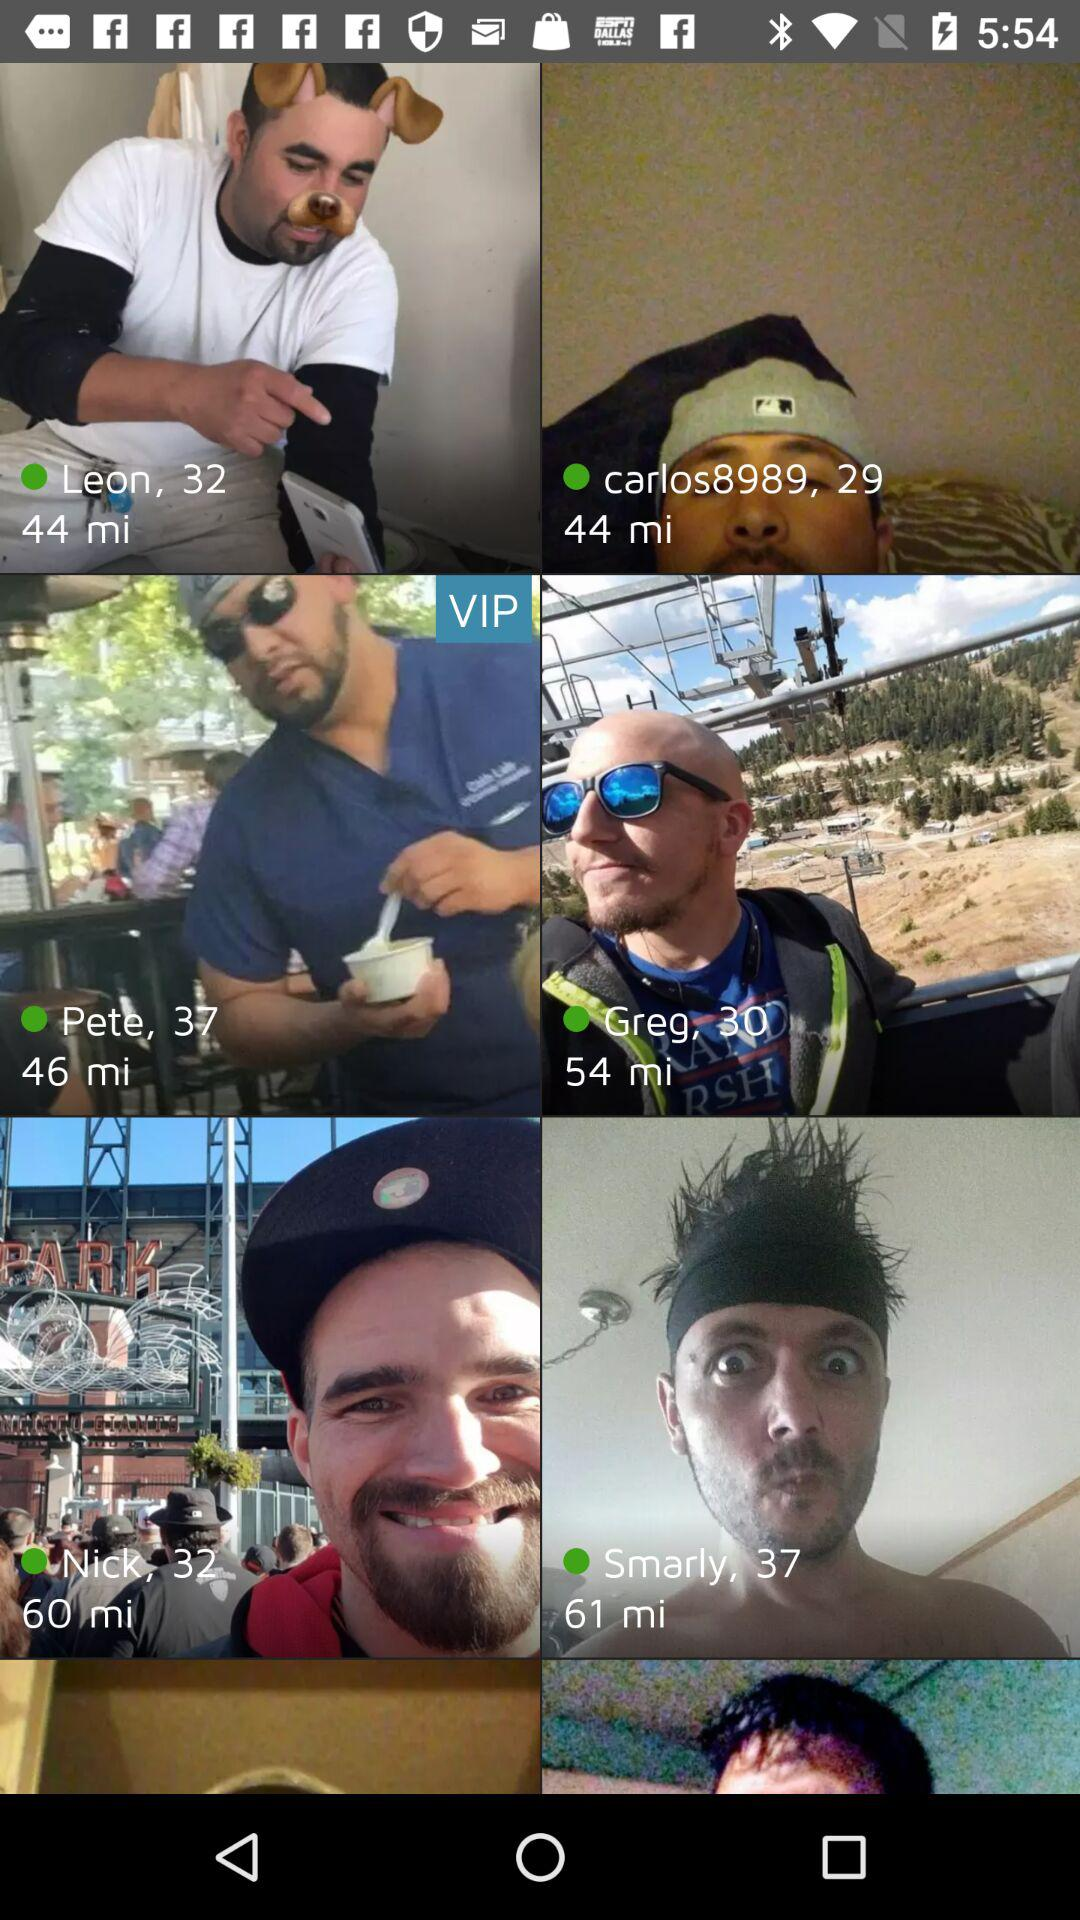How many minutes ago did Pete upload the image?
When the provided information is insufficient, respond with <no answer>. <no answer> 